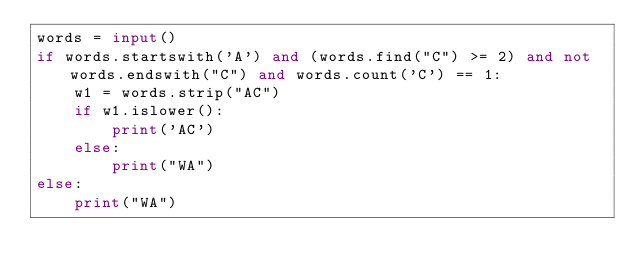Convert code to text. <code><loc_0><loc_0><loc_500><loc_500><_Python_>words = input()
if words.startswith('A') and (words.find("C") >= 2) and not words.endswith("C") and words.count('C') == 1:
    w1 = words.strip("AC")
    if w1.islower():
        print('AC')
    else:
        print("WA")
else:
    print("WA")</code> 